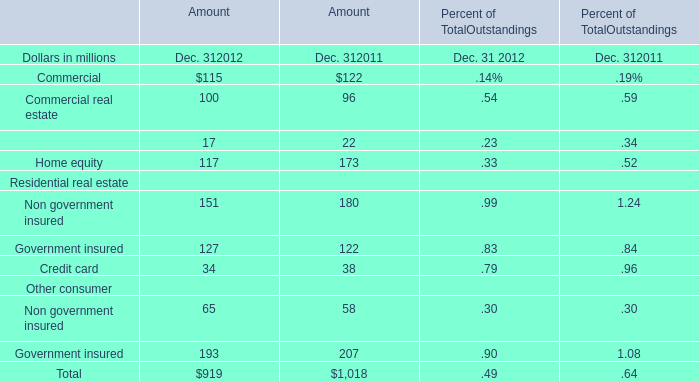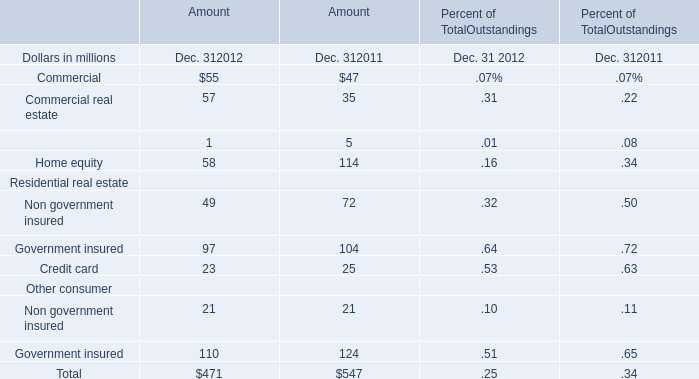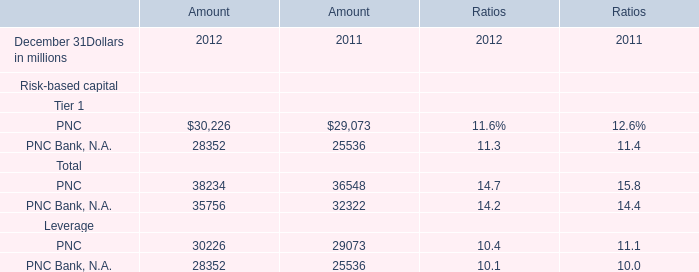What is the sum of Total Amount in 2012? (in million) 
Computations: ((((((((115 + 100) + 17) + 117) + 151) + 127) + 34) + 65) + 193)
Answer: 919.0. 